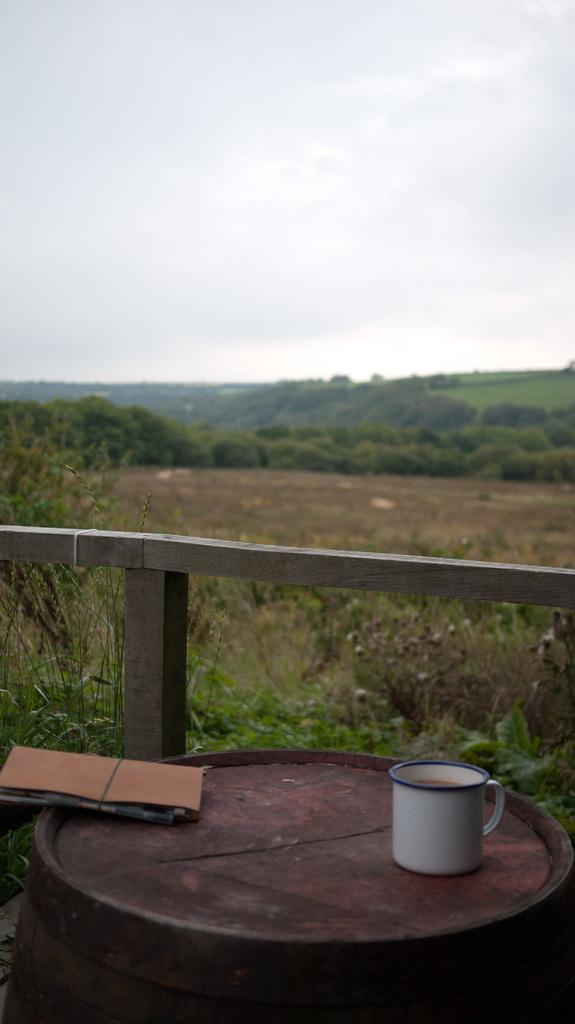What is located at the bottom of the image? There is a table at the bottom of the image. What objects are on the table? There is a mug and a file on the table. What can be seen in the background of the image? There is a fence, grass, trees, a hill, and the sky visible in the background of the image. Is there any quicksand visible in the image? No, there is no quicksand present in the image. Can you tell me how many people are swimming in the image? There are no people swimming in the image. 